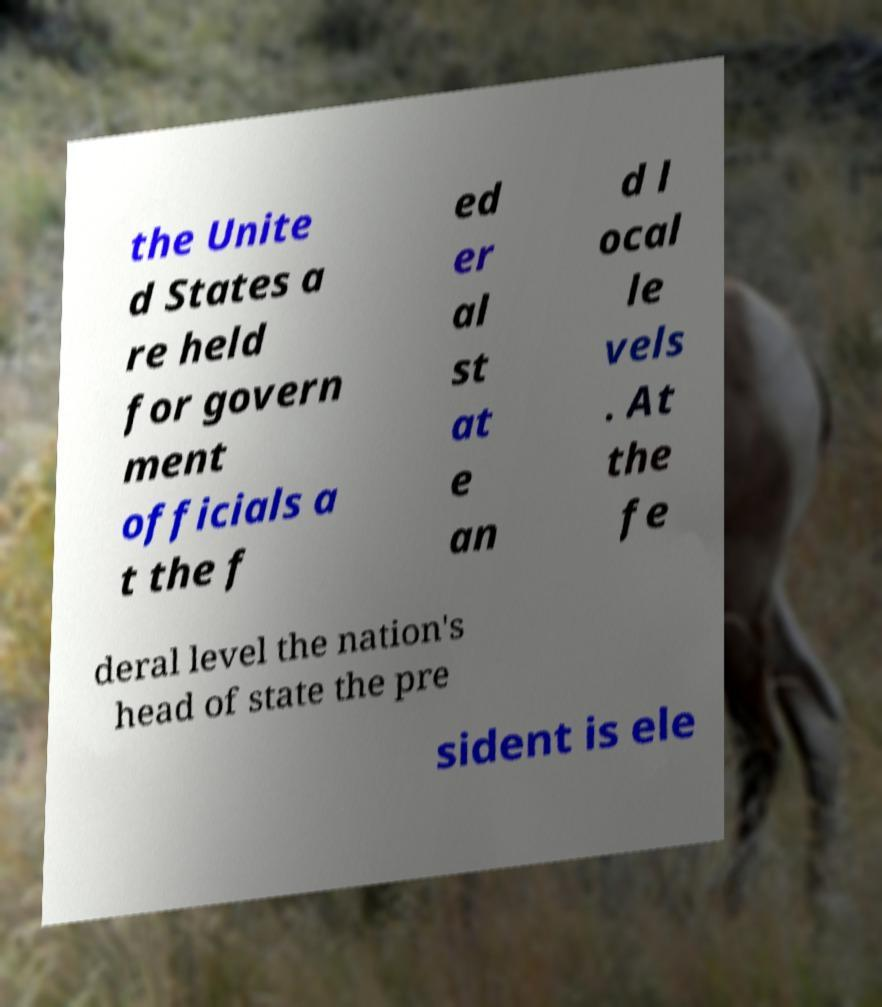Could you extract and type out the text from this image? the Unite d States a re held for govern ment officials a t the f ed er al st at e an d l ocal le vels . At the fe deral level the nation's head of state the pre sident is ele 